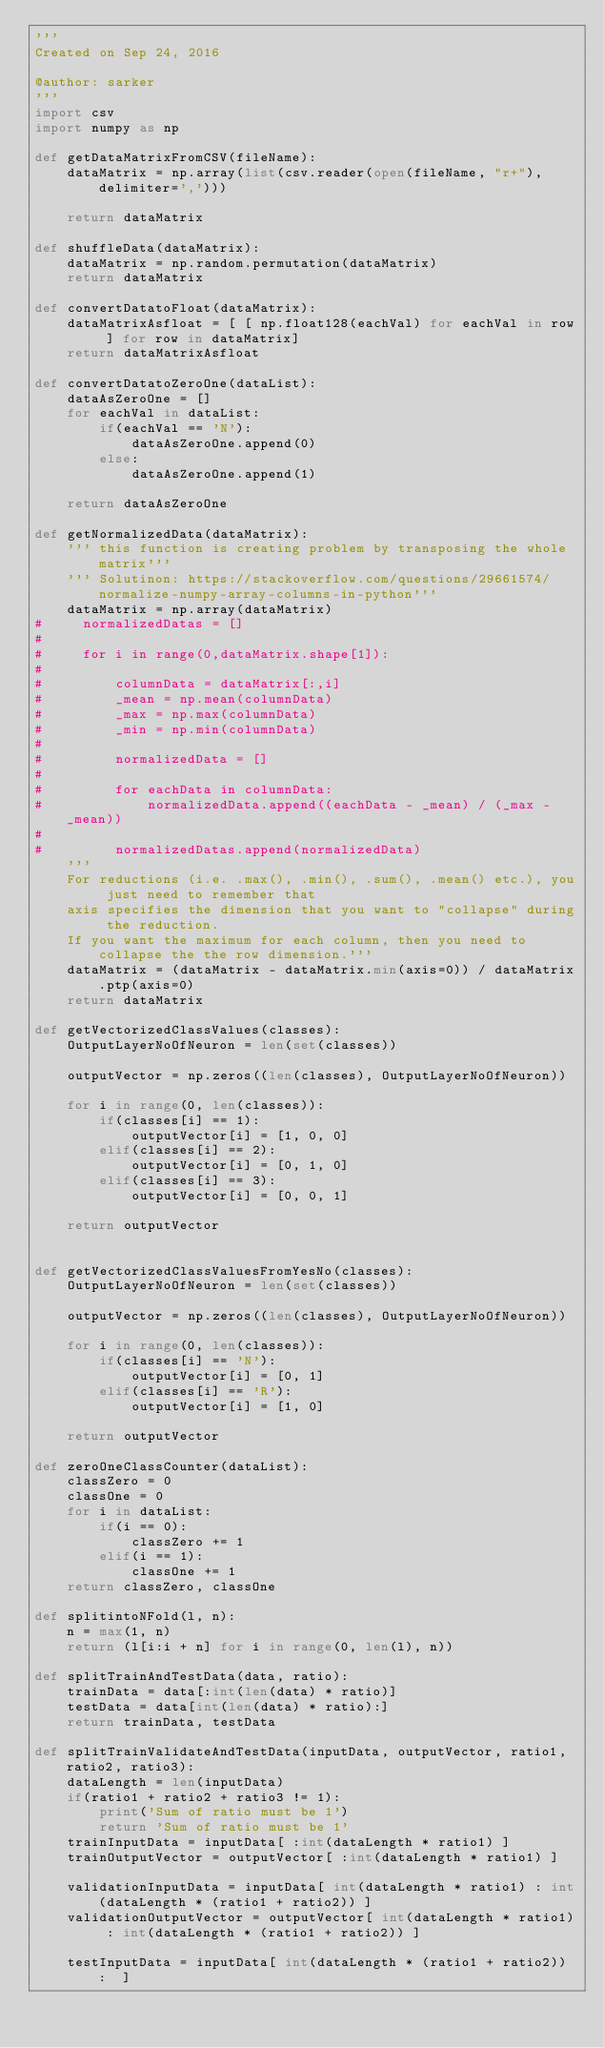<code> <loc_0><loc_0><loc_500><loc_500><_Python_>'''
Created on Sep 24, 2016

@author: sarker
'''
import csv
import numpy as np

def getDataMatrixFromCSV(fileName):
    dataMatrix = np.array(list(csv.reader(open(fileName, "r+"), delimiter=',')))
    
    return dataMatrix

def shuffleData(dataMatrix):
    dataMatrix = np.random.permutation(dataMatrix)
    return dataMatrix

def convertDatatoFloat(dataMatrix):
    dataMatrixAsfloat = [ [ np.float128(eachVal) for eachVal in row ] for row in dataMatrix]
    return dataMatrixAsfloat   

def convertDatatoZeroOne(dataList):
    dataAsZeroOne = [] 
    for eachVal in dataList:
        if(eachVal == 'N'):
            dataAsZeroOne.append(0)
        else:
            dataAsZeroOne.append(1)
 
    return dataAsZeroOne 

def getNormalizedData(dataMatrix):
    ''' this function is creating problem by transposing the whole matrix'''
    ''' Solutinon: https://stackoverflow.com/questions/29661574/normalize-numpy-array-columns-in-python'''
    dataMatrix = np.array(dataMatrix)
#     normalizedDatas = []
#
#     for i in range(0,dataMatrix.shape[1]):
#
#         columnData = dataMatrix[:,i]
#         _mean = np.mean(columnData)
#         _max = np.max(columnData)
#         _min = np.min(columnData)
#
#         normalizedData = []
#
#         for eachData in columnData:
#             normalizedData.append((eachData - _mean) / (_max - _mean))
#
#         normalizedDatas.append(normalizedData)
    '''    
    For reductions (i.e. .max(), .min(), .sum(), .mean() etc.), you just need to remember that 
    axis specifies the dimension that you want to "collapse" during the reduction. 
    If you want the maximum for each column, then you need to collapse the the row dimension.'''
    dataMatrix = (dataMatrix - dataMatrix.min(axis=0)) / dataMatrix.ptp(axis=0)
    return dataMatrix

def getVectorizedClassValues(classes):
    OutputLayerNoOfNeuron = len(set(classes)) 

    outputVector = np.zeros((len(classes), OutputLayerNoOfNeuron))

    for i in range(0, len(classes)):
        if(classes[i] == 1):
            outputVector[i] = [1, 0, 0]
        elif(classes[i] == 2):
            outputVector[i] = [0, 1, 0]
        elif(classes[i] == 3):
            outputVector[i] = [0, 0, 1]
       
    return outputVector


def getVectorizedClassValuesFromYesNo(classes):
    OutputLayerNoOfNeuron = len(set(classes)) 

    outputVector = np.zeros((len(classes), OutputLayerNoOfNeuron))

    for i in range(0, len(classes)):
        if(classes[i] == 'N'):
            outputVector[i] = [0, 1]
        elif(classes[i] == 'R'):
            outputVector[i] = [1, 0]
       
    return outputVector

def zeroOneClassCounter(dataList):
    classZero = 0
    classOne = 0
    for i in dataList:
        if(i == 0):
            classZero += 1
        elif(i == 1):
            classOne += 1
    return classZero, classOne

def splitintoNFold(l, n):
    n = max(1, n)
    return (l[i:i + n] for i in range(0, len(l), n))

def splitTrainAndTestData(data, ratio):
    trainData = data[:int(len(data) * ratio)]
    testData = data[int(len(data) * ratio):]
    return trainData, testData

def splitTrainValidateAndTestData(inputData, outputVector, ratio1, ratio2, ratio3):
    dataLength = len(inputData)
    if(ratio1 + ratio2 + ratio3 != 1):
        print('Sum of ratio must be 1')
        return 'Sum of ratio must be 1'
    trainInputData = inputData[ :int(dataLength * ratio1) ]
    trainOutputVector = outputVector[ :int(dataLength * ratio1) ]
    
    validationInputData = inputData[ int(dataLength * ratio1) : int(dataLength * (ratio1 + ratio2)) ]
    validationOutputVector = outputVector[ int(dataLength * ratio1) : int(dataLength * (ratio1 + ratio2)) ]
    
    testInputData = inputData[ int(dataLength * (ratio1 + ratio2)) :  ]</code> 